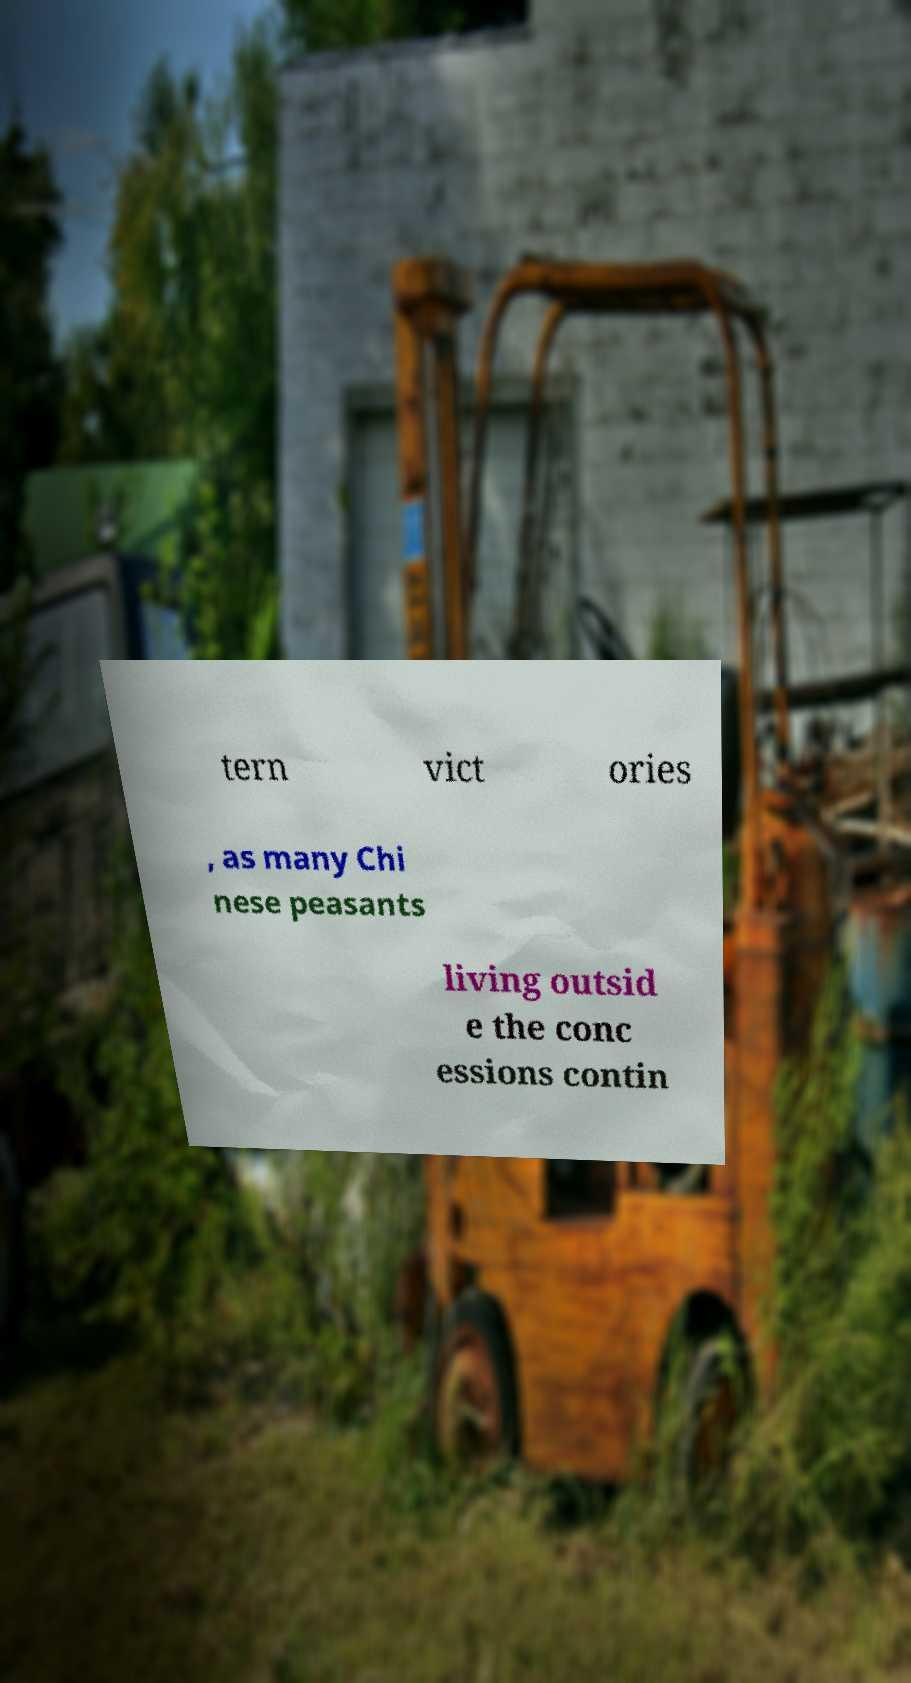There's text embedded in this image that I need extracted. Can you transcribe it verbatim? tern vict ories , as many Chi nese peasants living outsid e the conc essions contin 